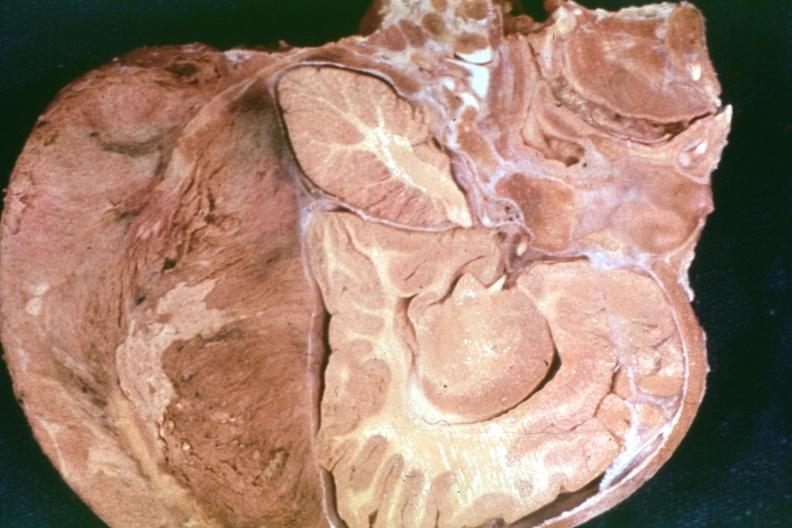what is present?
Answer the question using a single word or phrase. Metastatic neuroblastoma 